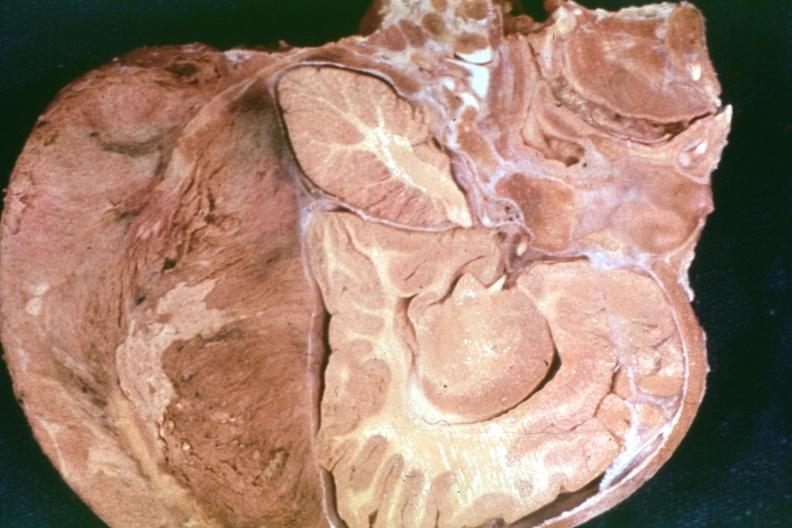what is present?
Answer the question using a single word or phrase. Metastatic neuroblastoma 